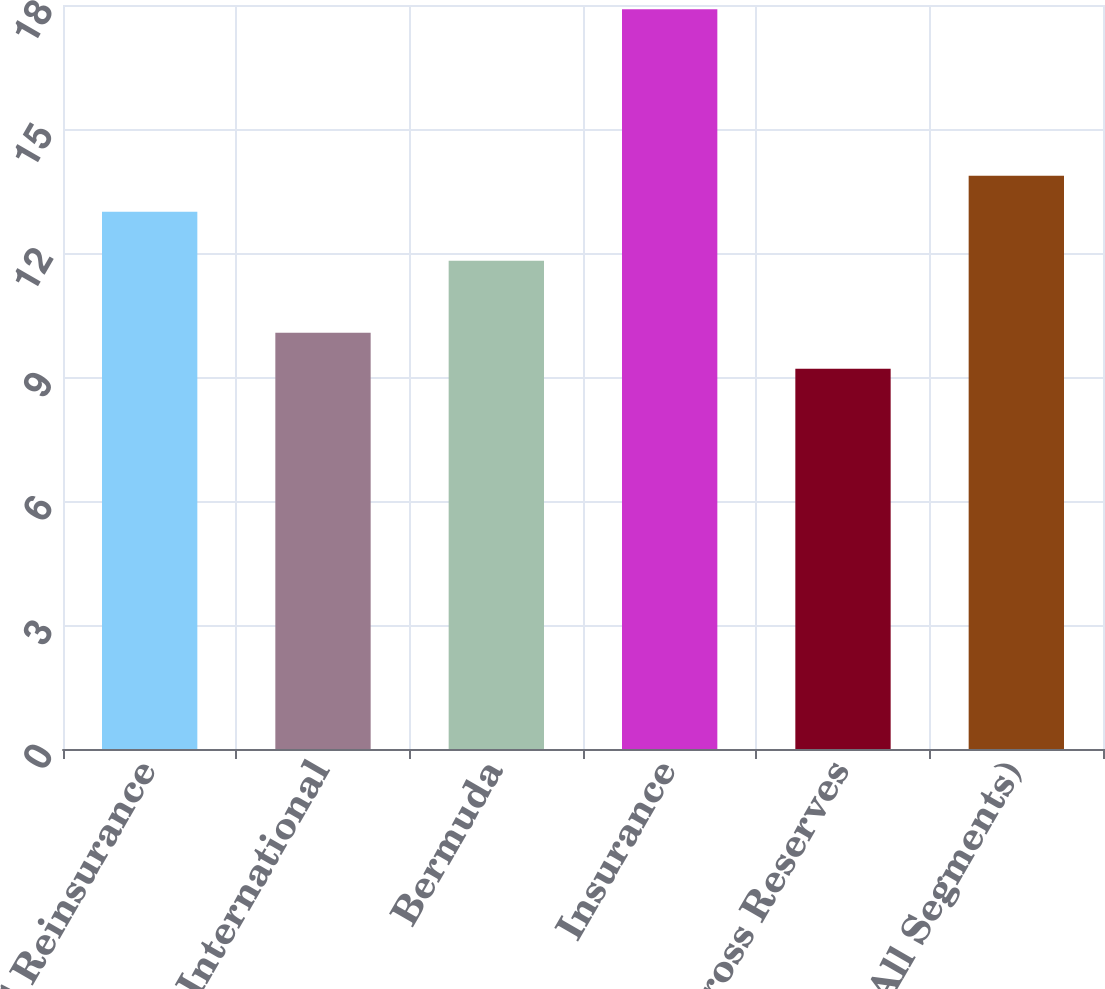<chart> <loc_0><loc_0><loc_500><loc_500><bar_chart><fcel>US Reinsurance<fcel>International<fcel>Bermuda<fcel>Insurance<fcel>Total Gross Reserves<fcel>A&E (All Segments)<nl><fcel>13<fcel>10.07<fcel>11.81<fcel>17.9<fcel>9.2<fcel>13.87<nl></chart> 